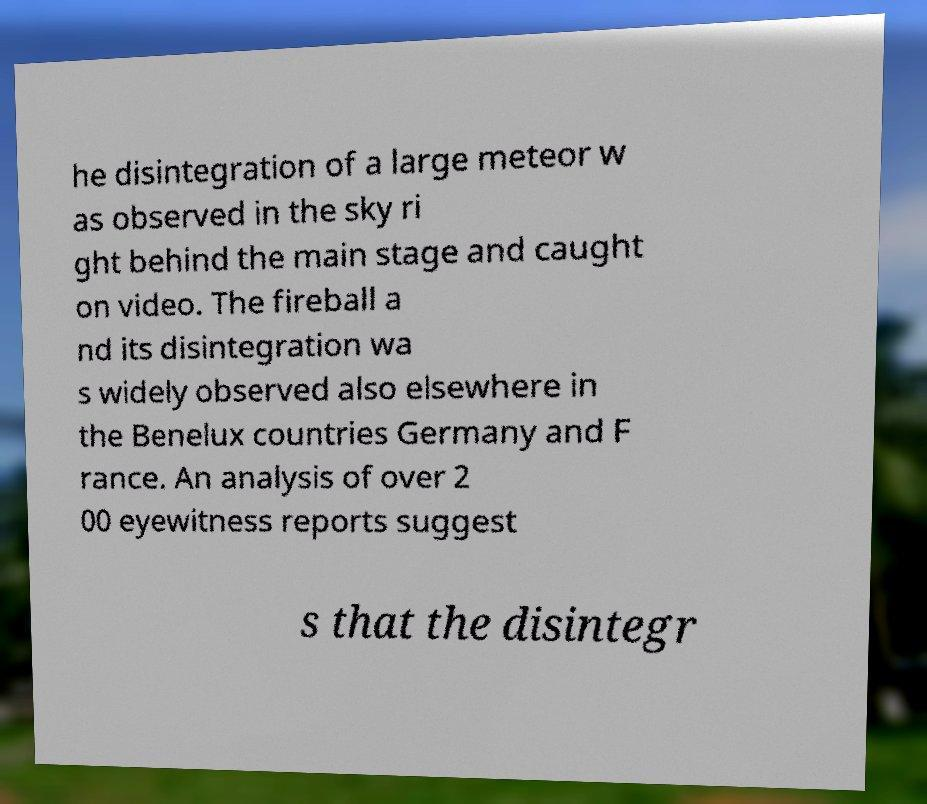Could you assist in decoding the text presented in this image and type it out clearly? he disintegration of a large meteor w as observed in the sky ri ght behind the main stage and caught on video. The fireball a nd its disintegration wa s widely observed also elsewhere in the Benelux countries Germany and F rance. An analysis of over 2 00 eyewitness reports suggest s that the disintegr 